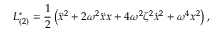<formula> <loc_0><loc_0><loc_500><loc_500>{ L } _ { ( 2 ) } ^ { * } = \frac { 1 } { 2 } \left ( \ddot { x } ^ { 2 } + 2 \omega ^ { 2 } \ddot { x } x + 4 \omega ^ { 2 } \zeta ^ { 2 } \dot { x } ^ { 2 } + \omega ^ { 4 } x ^ { 2 } \right ) ,</formula> 